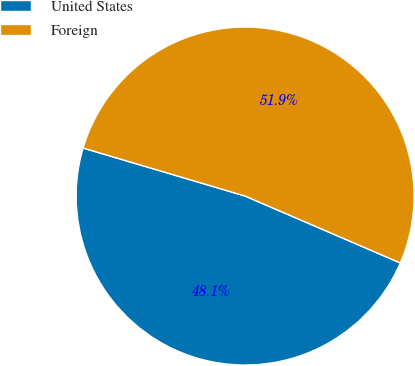Convert chart to OTSL. <chart><loc_0><loc_0><loc_500><loc_500><pie_chart><fcel>United States<fcel>Foreign<nl><fcel>48.11%<fcel>51.89%<nl></chart> 